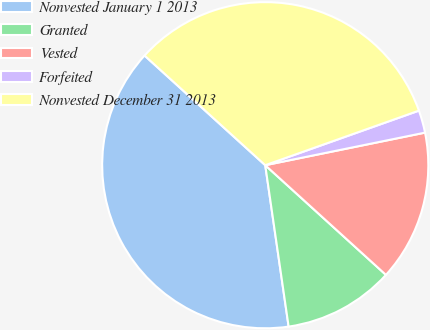Convert chart to OTSL. <chart><loc_0><loc_0><loc_500><loc_500><pie_chart><fcel>Nonvested January 1 2013<fcel>Granted<fcel>Vested<fcel>Forfeited<fcel>Nonvested December 31 2013<nl><fcel>39.03%<fcel>10.97%<fcel>14.94%<fcel>2.23%<fcel>32.83%<nl></chart> 